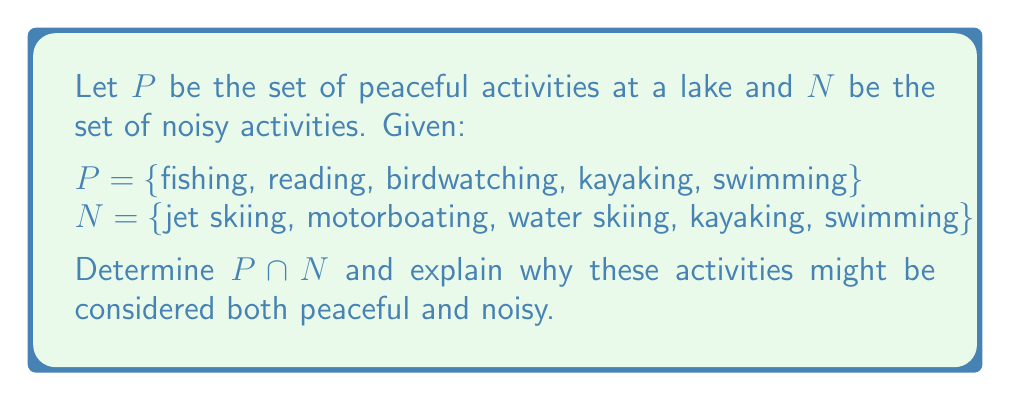Give your solution to this math problem. To find the intersection of sets $P$ and $N$, we need to identify the elements that are present in both sets.

1. First, let's list out the elements of each set:
   $P = \{$fishing, reading, birdwatching, kayaking, swimming$\}$
   $N = \{$jet skiing, motorboating, water skiing, kayaking, swimming$\}$

2. Now, we compare the elements of both sets to find common elements:
   - fishing: only in $P$
   - reading: only in $P$
   - birdwatching: only in $P$
   - kayaking: in both $P$ and $N$
   - swimming: in both $P$ and $N$
   - jet skiing: only in $N$
   - motorboating: only in $N$
   - water skiing: only in $N$

3. The intersection $P \cap N$ contains the elements present in both sets:
   $P \cap N = \{$kayaking, swimming$\}$

4. Explanation of why these activities might be considered both peaceful and noisy:
   - Kayaking: While generally a quiet activity, the splashing of paddles and movement through water can create some noise. It's peaceful for the person kayaking but might be perceived as slightly noisy by others.
   - Swimming: Similar to kayaking, swimming can be a serene experience for the swimmer, but the splashing and potential conversations can contribute to lake noise.

These activities represent a balance between the tranquility desired by the quiet retiree and the inevitable sounds associated with lake recreation.
Answer: $P \cap N = \{$kayaking, swimming$\}$ 